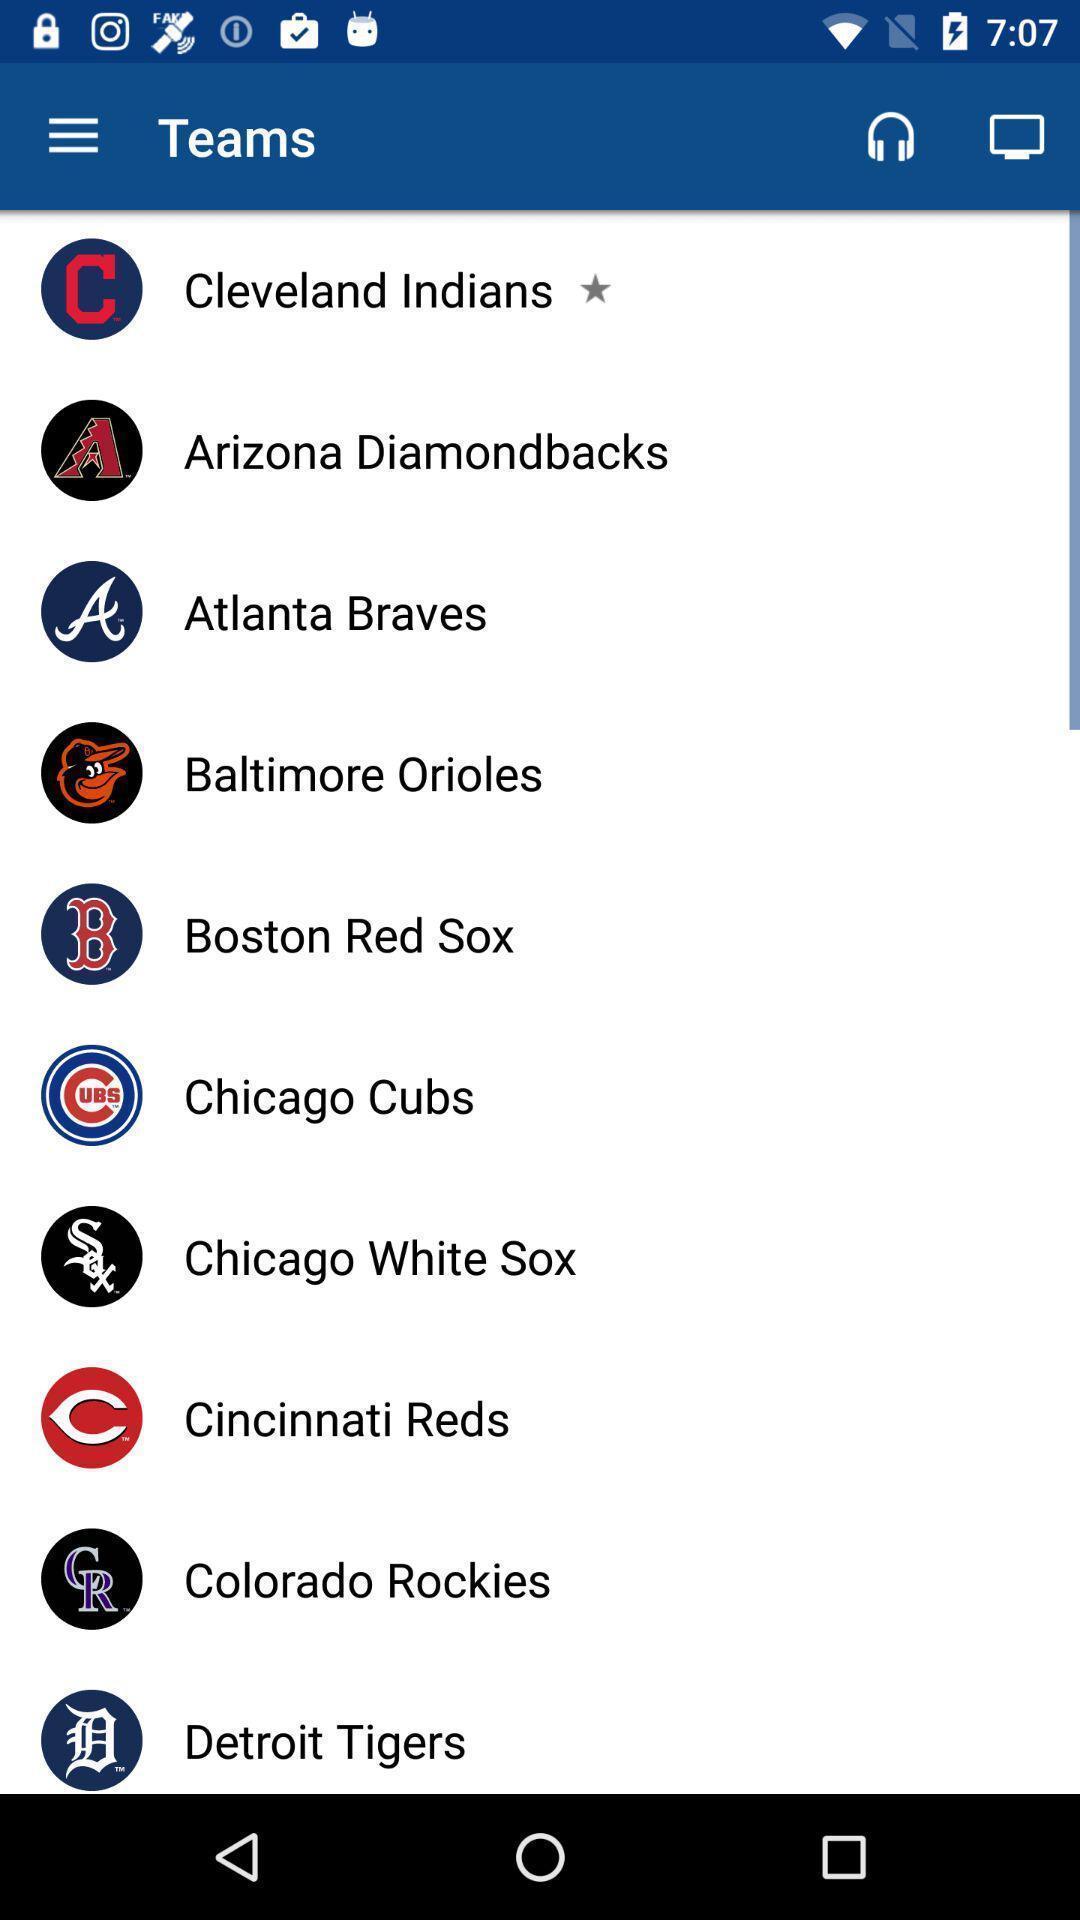Summarize the main components in this picture. Teams list showing in application. 